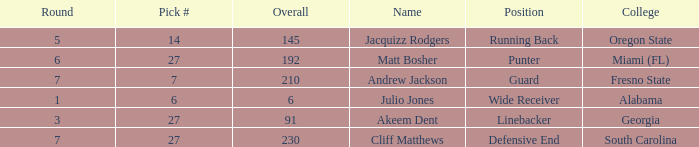Which highest pick number had Akeem Dent as a name and where the overall was less than 91? None. 